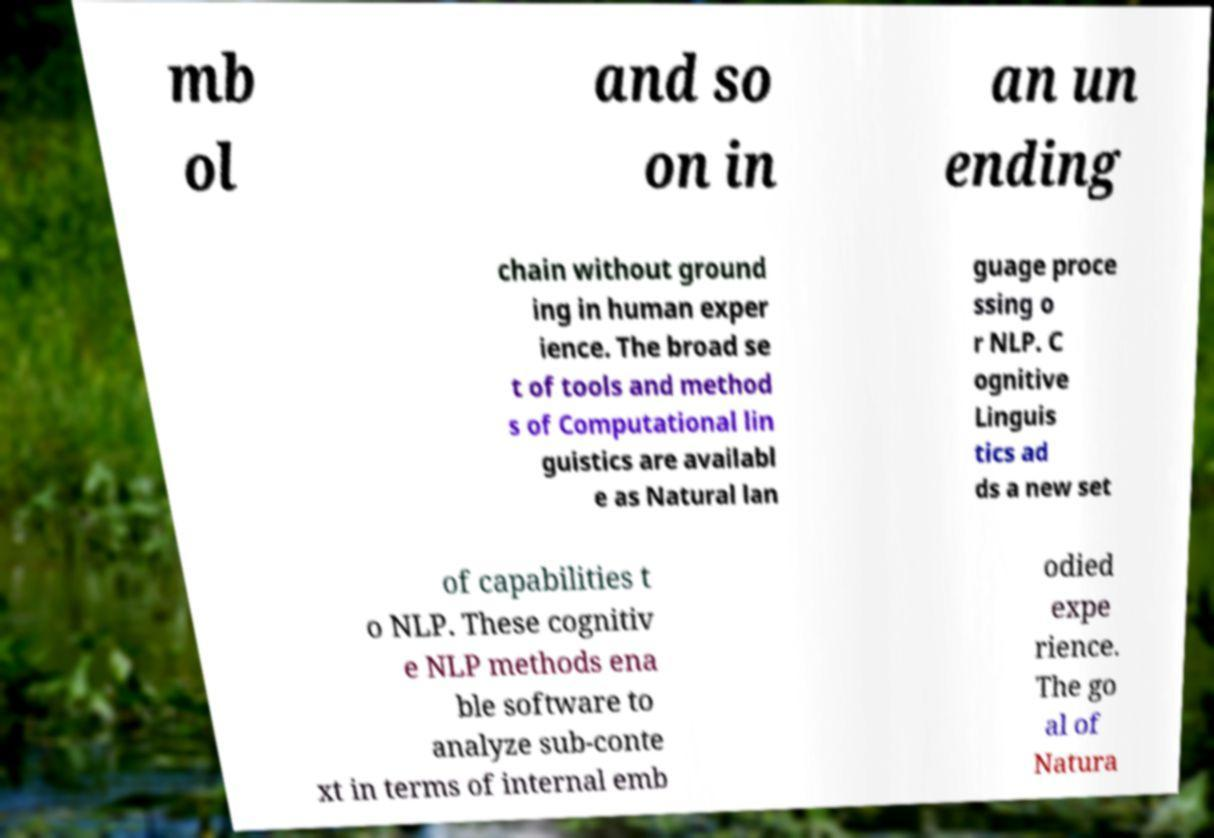What messages or text are displayed in this image? I need them in a readable, typed format. mb ol and so on in an un ending chain without ground ing in human exper ience. The broad se t of tools and method s of Computational lin guistics are availabl e as Natural lan guage proce ssing o r NLP. C ognitive Linguis tics ad ds a new set of capabilities t o NLP. These cognitiv e NLP methods ena ble software to analyze sub-conte xt in terms of internal emb odied expe rience. The go al of Natura 